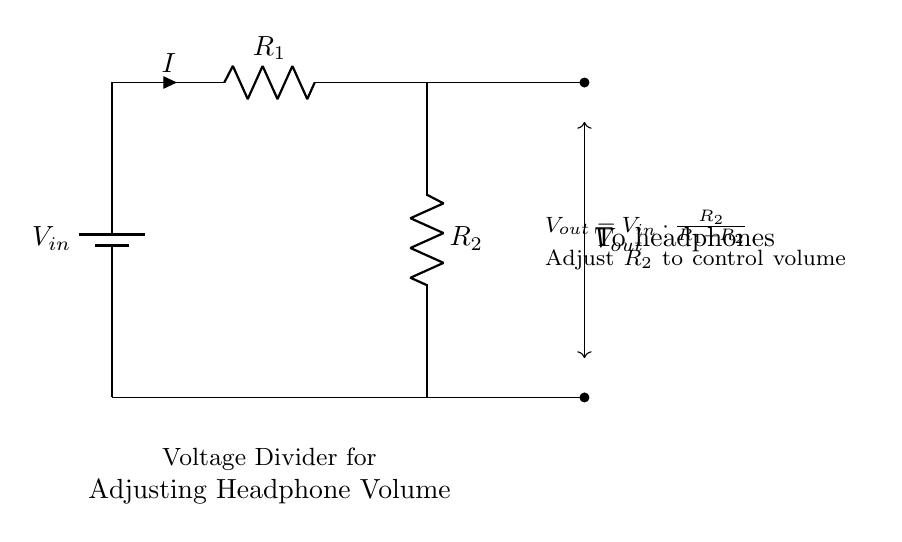What is the role of R1 in this circuit? R1 determines the overall resistance in the voltage divider setup, affecting the current flowing through the circuit and subsequently the output voltage.
Answer: Resistance R1 What is the significance of Vout? Vout is the output voltage available for the headphones, determined by the ratio of R2 to the total resistance of R1 and R2, directly affecting volume adjustment.
Answer: Output voltage What happens to Vout if R2 increases? If R2 increases, Vout rises, as more voltage is dropped across R2 due to its larger value in comparison to R1, thus increasing the audio signal sent to the headphones.
Answer: Vout increases What type of circuit is this? This is a voltage divider circuit specifically designed for adjusting volume levels in audio applications, such as for headphones in portable music players.
Answer: Voltage divider What is the formula for Vout? The formula for Vout in a voltage divider is Vout equals Vin times the ratio of R2 over the sum of R1 and R2, which calculates the voltage delivered to the headphones.
Answer: Vout equals Vin times R2 over (R1 plus R2) What does adjusting R2 accomplish in this circuit? Adjusting R2 changes the amount of voltage drop across it, effectively altering the volume of the audio signal sent to the headphones, allowing for finer control over listening levels.
Answer: Adjusts audio volume What is the current in this circuit represented by? The current, denoted as I, is the flow of electric charge through the resistors R1 and R2, which is the same for both resistors in a series configuration of this voltage divider.
Answer: I, the current 